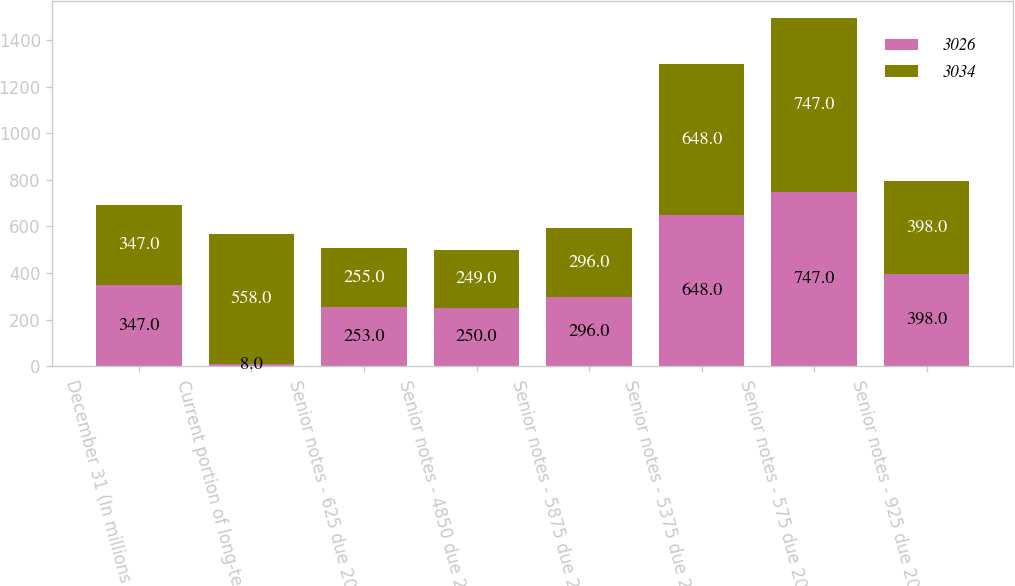Convert chart to OTSL. <chart><loc_0><loc_0><loc_500><loc_500><stacked_bar_chart><ecel><fcel>December 31 (In millions of<fcel>Current portion of long-term<fcel>Senior notes - 625 due 2012<fcel>Senior notes - 4850 due 2013<fcel>Senior notes - 5875 due 2033<fcel>Senior notes - 5375 due 2014<fcel>Senior notes - 575 due 2015<fcel>Senior notes - 925 due 2019<nl><fcel>3026<fcel>347<fcel>8<fcel>253<fcel>250<fcel>296<fcel>648<fcel>747<fcel>398<nl><fcel>3034<fcel>347<fcel>558<fcel>255<fcel>249<fcel>296<fcel>648<fcel>747<fcel>398<nl></chart> 